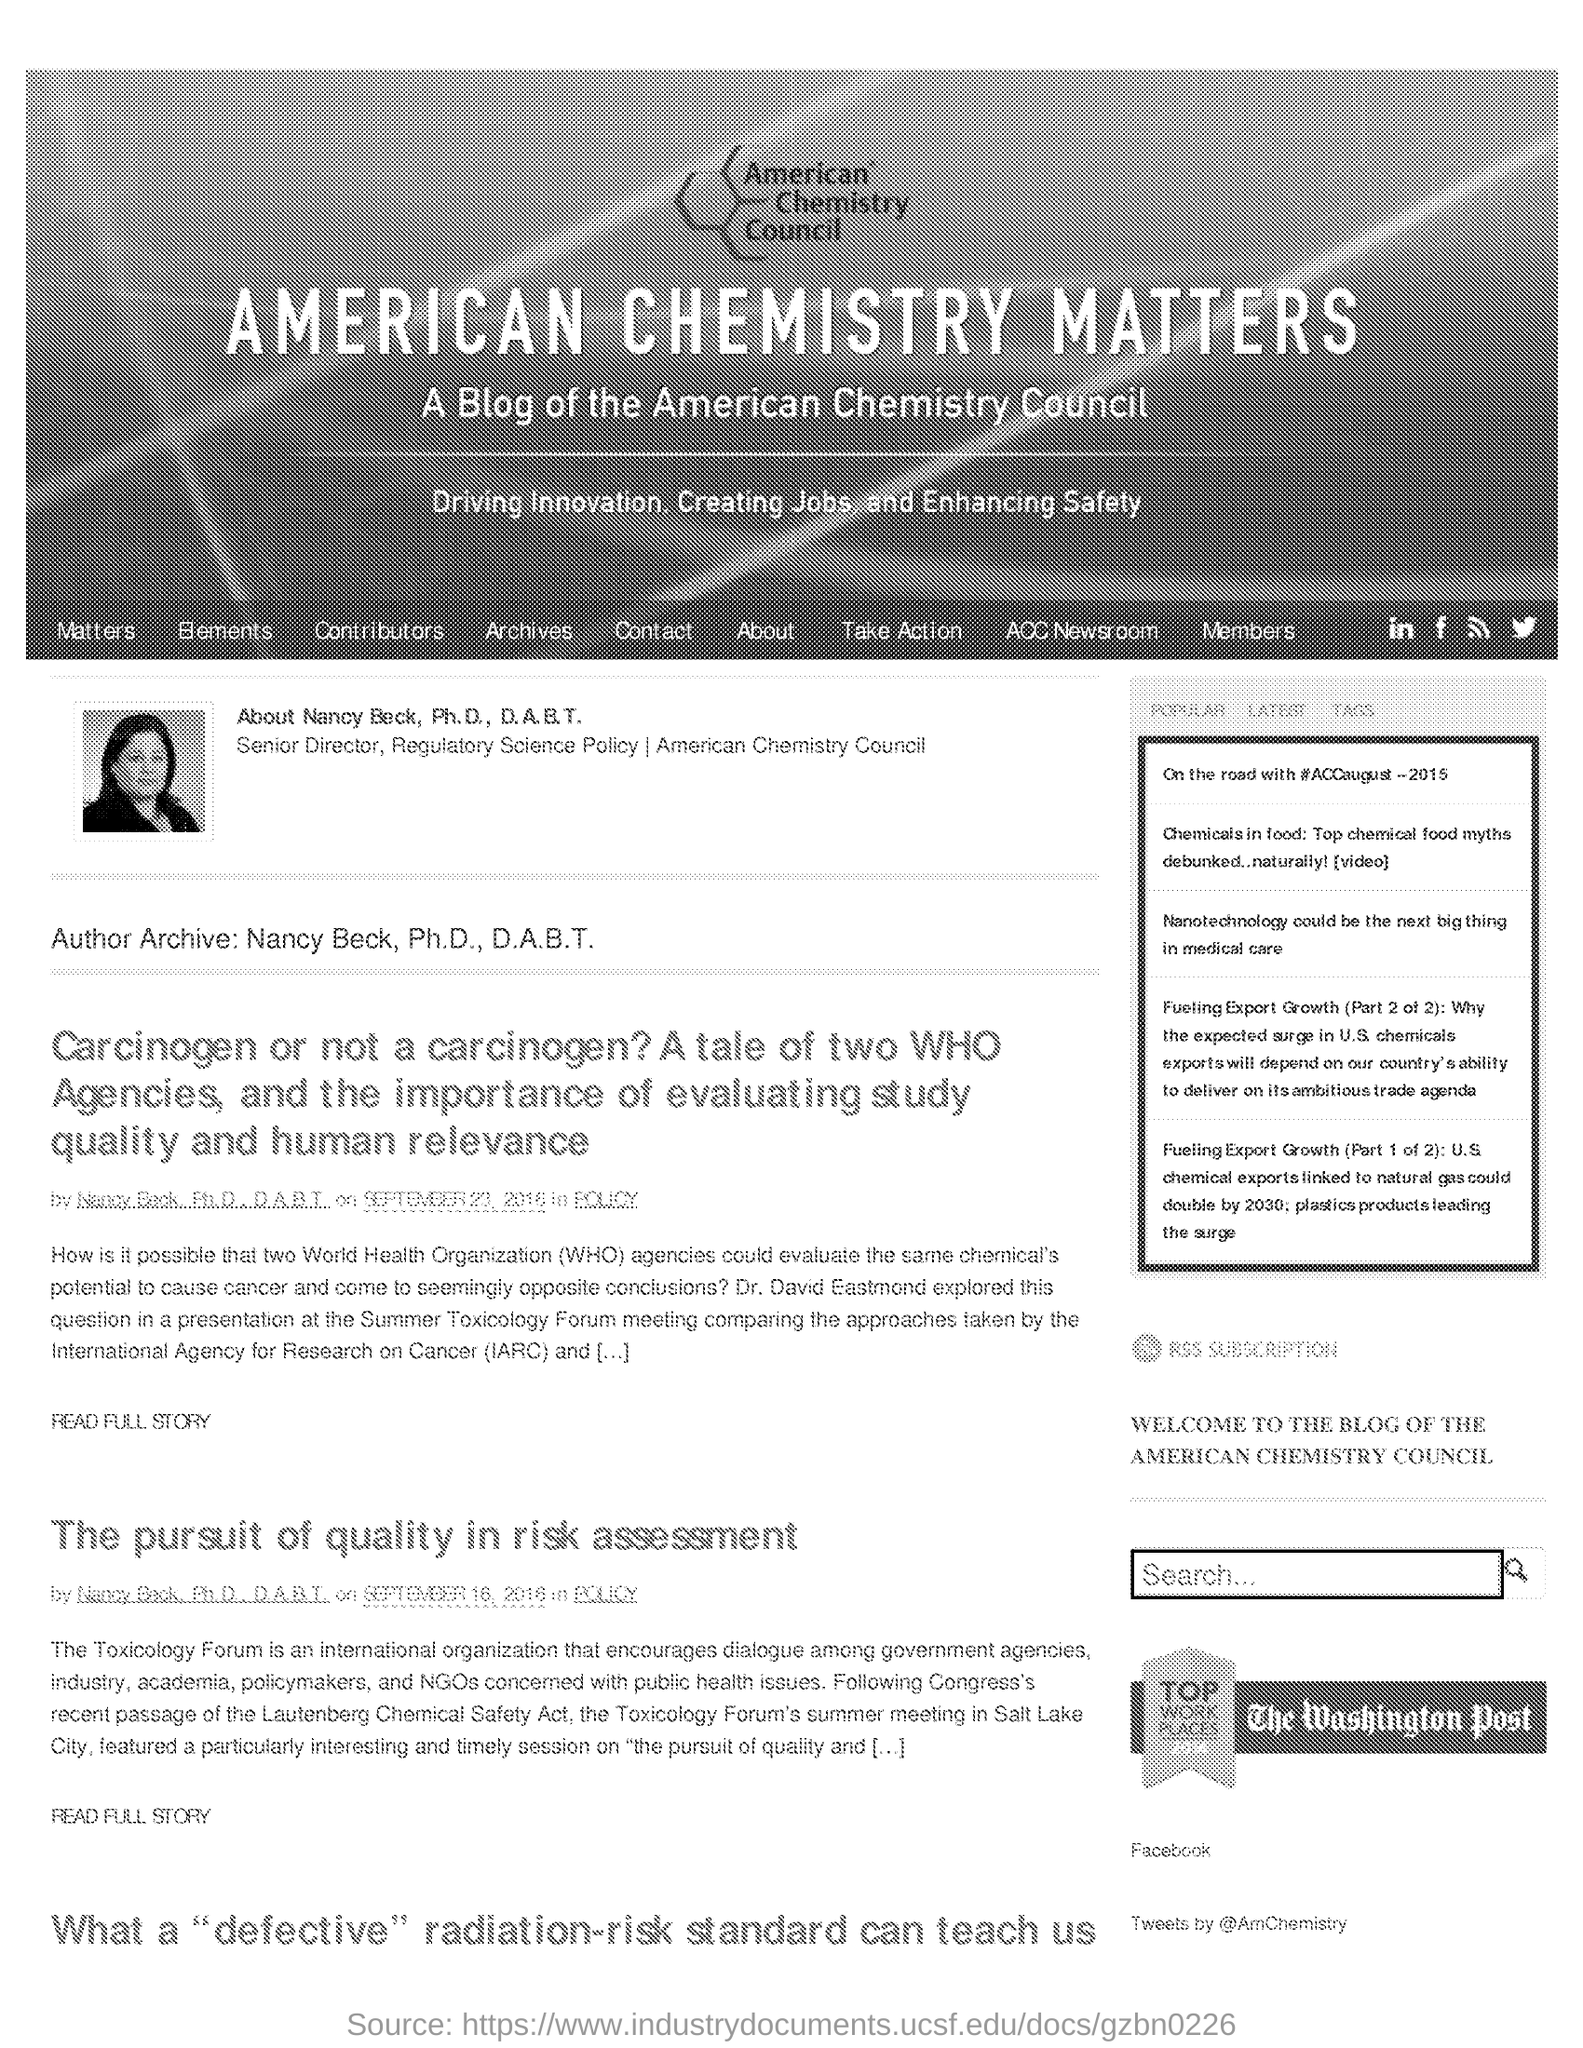Identify some key points in this picture. Nancy Beck, Ph.D., D.A.B.T, is the author of the blog page. The Toxicology Forum's summer meeting was held in Salt Lake City. 